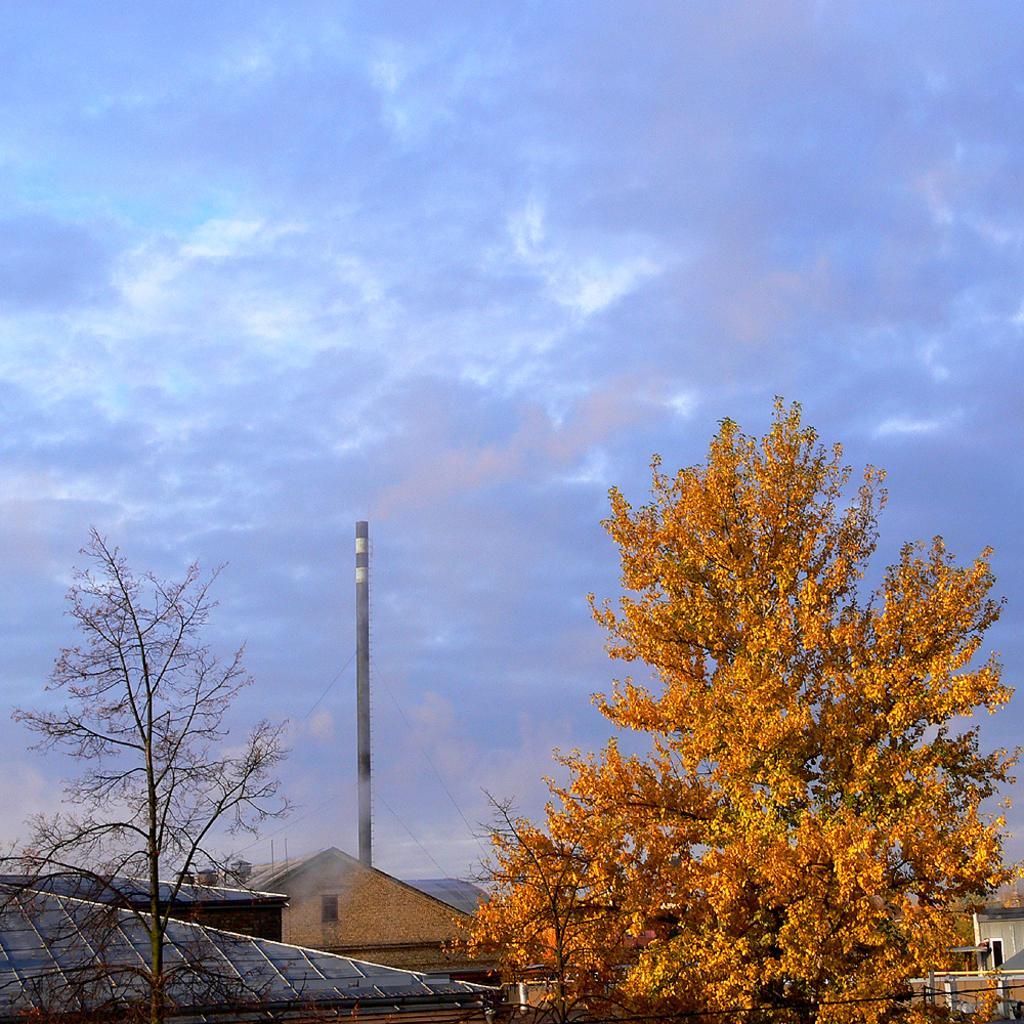In one or two sentences, can you explain what this image depicts? In this picture we can see a house, few trees and a pole in the background. Sky is cloudy. 